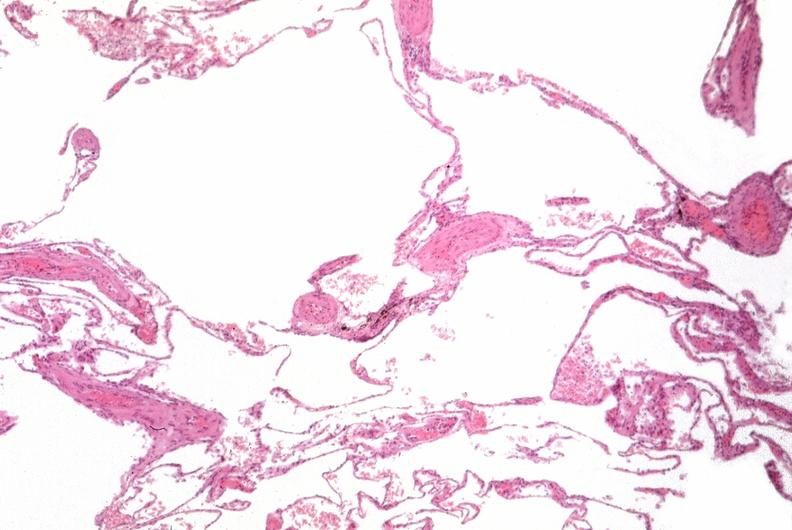does this image show lung, emphysema, alpha-1 antitrypsin deficiency?
Answer the question using a single word or phrase. Yes 